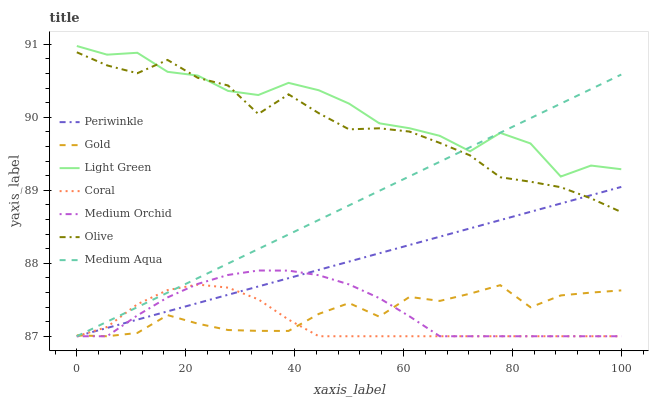Does Medium Orchid have the minimum area under the curve?
Answer yes or no. No. Does Medium Orchid have the maximum area under the curve?
Answer yes or no. No. Is Coral the smoothest?
Answer yes or no. No. Is Coral the roughest?
Answer yes or no. No. Does Light Green have the lowest value?
Answer yes or no. No. Does Coral have the highest value?
Answer yes or no. No. Is Gold less than Light Green?
Answer yes or no. Yes. Is Olive greater than Gold?
Answer yes or no. Yes. Does Gold intersect Light Green?
Answer yes or no. No. 